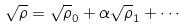Convert formula to latex. <formula><loc_0><loc_0><loc_500><loc_500>\sqrt { \rho } = \sqrt { \rho } _ { 0 } + \alpha \sqrt { \rho } _ { 1 } + \cdots</formula> 